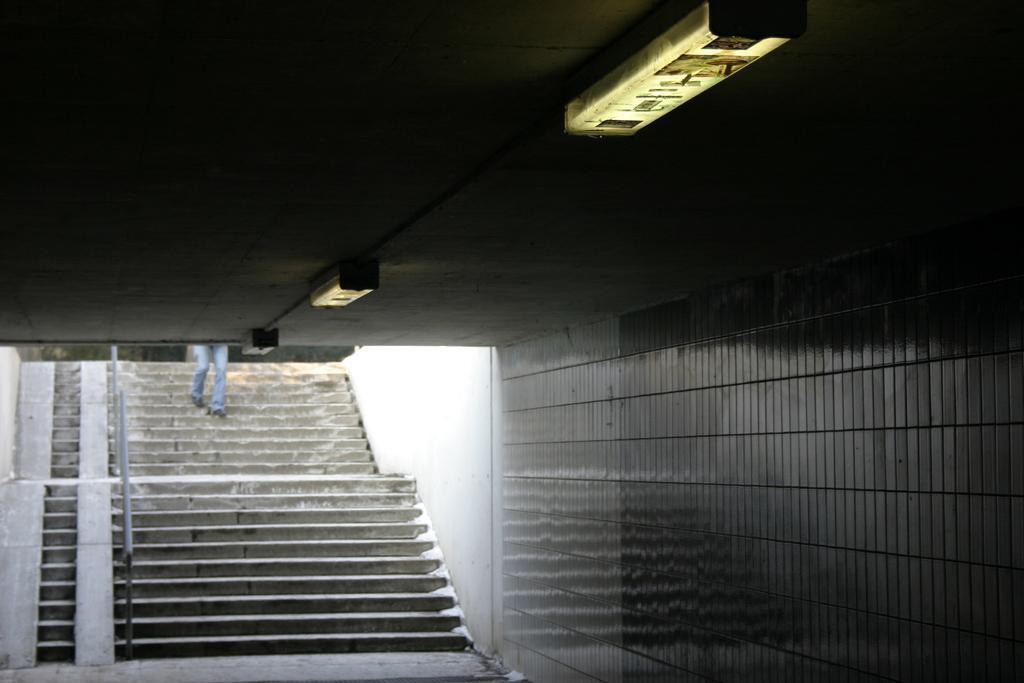Could you give a brief overview of what you see in this image? In this image I can see a building, lights, fence, staircase, person and trees. This image is taken may be during a day. 